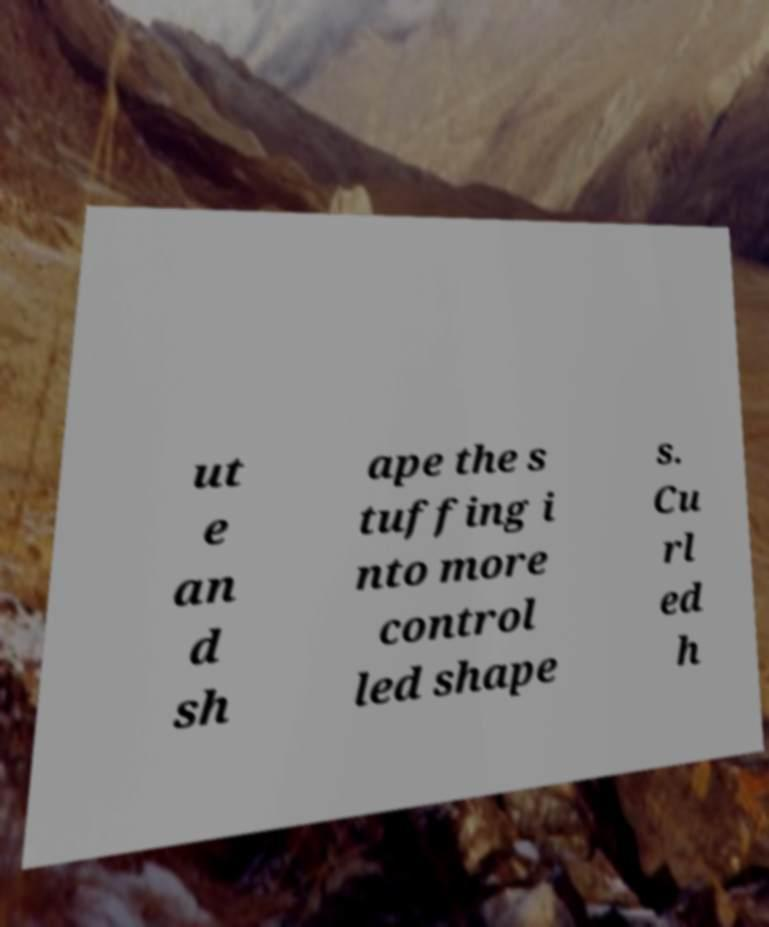Can you accurately transcribe the text from the provided image for me? ut e an d sh ape the s tuffing i nto more control led shape s. Cu rl ed h 